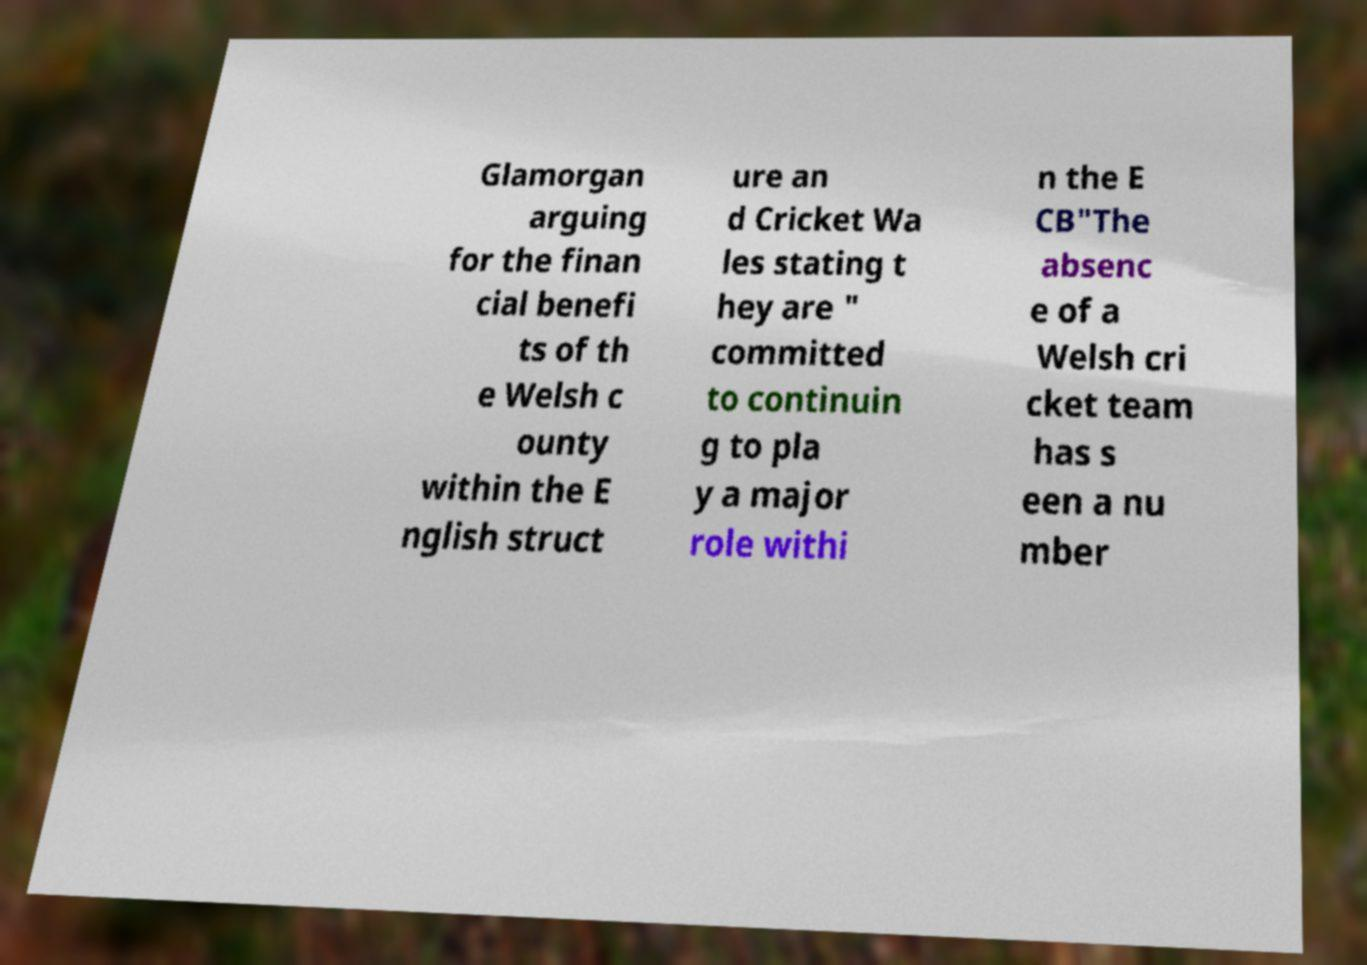Can you read and provide the text displayed in the image?This photo seems to have some interesting text. Can you extract and type it out for me? Glamorgan arguing for the finan cial benefi ts of th e Welsh c ounty within the E nglish struct ure an d Cricket Wa les stating t hey are " committed to continuin g to pla y a major role withi n the E CB"The absenc e of a Welsh cri cket team has s een a nu mber 